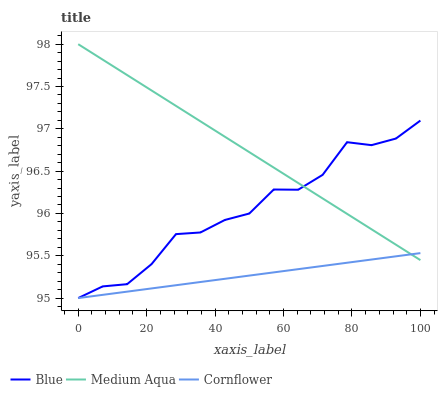Does Cornflower have the minimum area under the curve?
Answer yes or no. Yes. Does Medium Aqua have the maximum area under the curve?
Answer yes or no. Yes. Does Medium Aqua have the minimum area under the curve?
Answer yes or no. No. Does Cornflower have the maximum area under the curve?
Answer yes or no. No. Is Cornflower the smoothest?
Answer yes or no. Yes. Is Blue the roughest?
Answer yes or no. Yes. Is Medium Aqua the smoothest?
Answer yes or no. No. Is Medium Aqua the roughest?
Answer yes or no. No. Does Blue have the lowest value?
Answer yes or no. Yes. Does Medium Aqua have the lowest value?
Answer yes or no. No. Does Medium Aqua have the highest value?
Answer yes or no. Yes. Does Cornflower have the highest value?
Answer yes or no. No. Does Blue intersect Medium Aqua?
Answer yes or no. Yes. Is Blue less than Medium Aqua?
Answer yes or no. No. Is Blue greater than Medium Aqua?
Answer yes or no. No. 